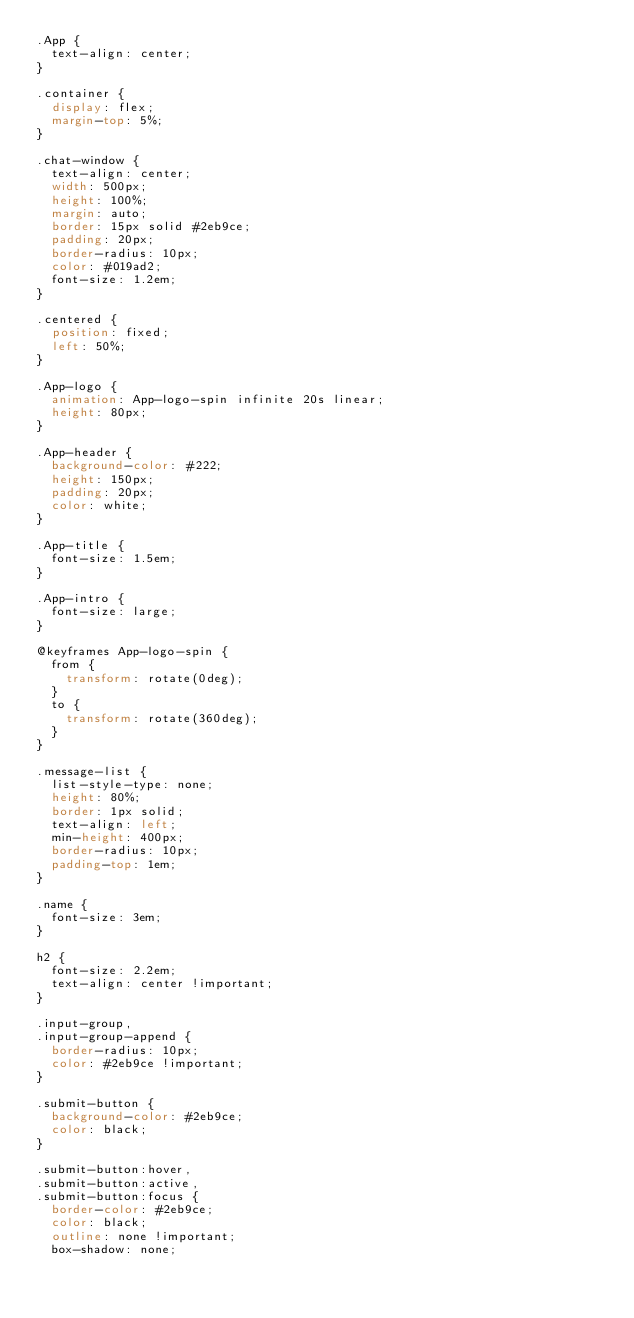Convert code to text. <code><loc_0><loc_0><loc_500><loc_500><_CSS_>.App {
  text-align: center;
}

.container {
  display: flex;
  margin-top: 5%;
}

.chat-window {
  text-align: center;
  width: 500px;
  height: 100%;
  margin: auto;
  border: 15px solid #2eb9ce;
  padding: 20px;
  border-radius: 10px;
  color: #019ad2;
  font-size: 1.2em;
}

.centered {
  position: fixed;
  left: 50%;
}

.App-logo {
  animation: App-logo-spin infinite 20s linear;
  height: 80px;
}

.App-header {
  background-color: #222;
  height: 150px;
  padding: 20px;
  color: white;
}

.App-title {
  font-size: 1.5em;
}

.App-intro {
  font-size: large;
}

@keyframes App-logo-spin {
  from {
    transform: rotate(0deg);
  }
  to {
    transform: rotate(360deg);
  }
}

.message-list {
  list-style-type: none;
  height: 80%;
  border: 1px solid;
  text-align: left;
  min-height: 400px;
  border-radius: 10px;
  padding-top: 1em;
}

.name {
  font-size: 3em;
}

h2 {
  font-size: 2.2em;
  text-align: center !important;
}

.input-group,
.input-group-append {
  border-radius: 10px;
  color: #2eb9ce !important;
}

.submit-button {
  background-color: #2eb9ce;
  color: black;
}

.submit-button:hover,
.submit-button:active,
.submit-button:focus {
  border-color: #2eb9ce;
  color: black;
  outline: none !important;
  box-shadow: none;</code> 